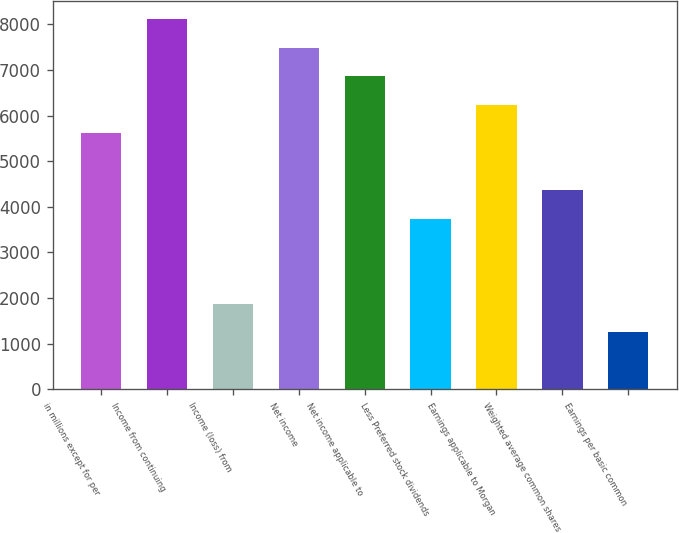Convert chart to OTSL. <chart><loc_0><loc_0><loc_500><loc_500><bar_chart><fcel>in millions except for per<fcel>Income from continuing<fcel>Income (loss) from<fcel>Net income<fcel>Net income applicable to<fcel>Less Preferred stock dividends<fcel>Earnings applicable to Morgan<fcel>Weighted average common shares<fcel>Earnings per basic common<nl><fcel>5611.78<fcel>8104.54<fcel>1872.64<fcel>7481.35<fcel>6858.16<fcel>3742.21<fcel>6234.97<fcel>4365.4<fcel>1249.45<nl></chart> 